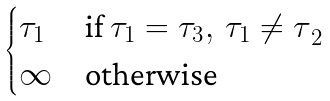<formula> <loc_0><loc_0><loc_500><loc_500>\begin{cases} \tau _ { 1 } & \text {if $\tau _{1} =\tau _{3},\,\tau _{1}\neq \tau $} _ { 2 } \\ \infty & \text {otherwise} \end{cases}</formula> 